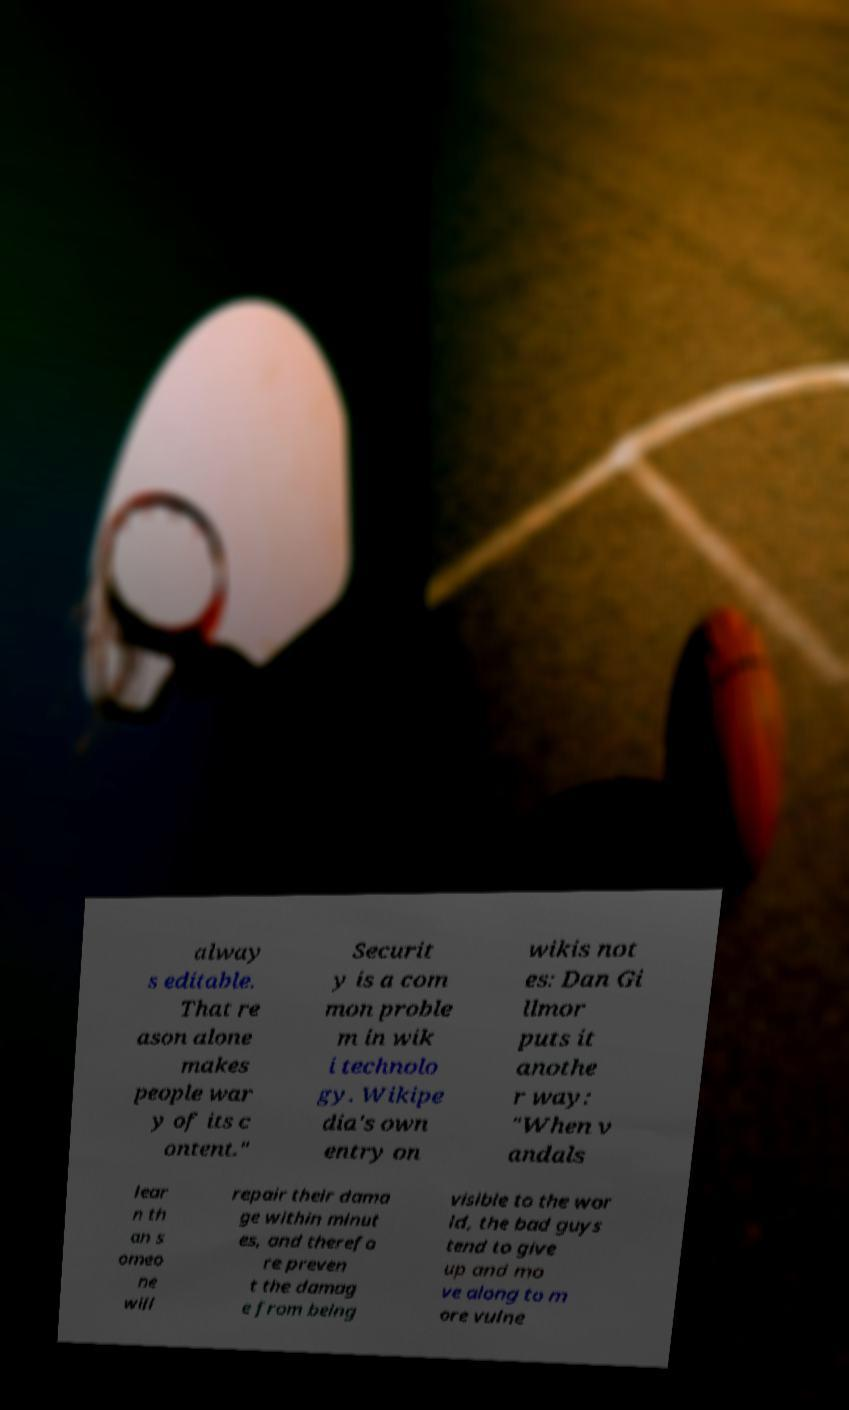For documentation purposes, I need the text within this image transcribed. Could you provide that? alway s editable. That re ason alone makes people war y of its c ontent." Securit y is a com mon proble m in wik i technolo gy. Wikipe dia's own entry on wikis not es: Dan Gi llmor puts it anothe r way: "When v andals lear n th an s omeo ne will repair their dama ge within minut es, and therefo re preven t the damag e from being visible to the wor ld, the bad guys tend to give up and mo ve along to m ore vulne 